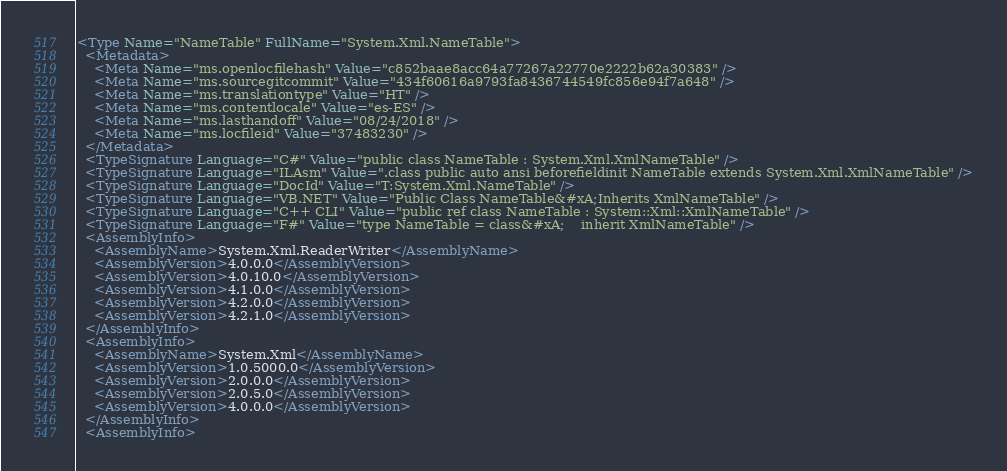<code> <loc_0><loc_0><loc_500><loc_500><_XML_><Type Name="NameTable" FullName="System.Xml.NameTable">
  <Metadata>
    <Meta Name="ms.openlocfilehash" Value="c852baae8acc64a77267a22770e2222b62a30383" />
    <Meta Name="ms.sourcegitcommit" Value="434f60616a9793fa8436744549fc856e94f7a648" />
    <Meta Name="ms.translationtype" Value="HT" />
    <Meta Name="ms.contentlocale" Value="es-ES" />
    <Meta Name="ms.lasthandoff" Value="08/24/2018" />
    <Meta Name="ms.locfileid" Value="37483230" />
  </Metadata>
  <TypeSignature Language="C#" Value="public class NameTable : System.Xml.XmlNameTable" />
  <TypeSignature Language="ILAsm" Value=".class public auto ansi beforefieldinit NameTable extends System.Xml.XmlNameTable" />
  <TypeSignature Language="DocId" Value="T:System.Xml.NameTable" />
  <TypeSignature Language="VB.NET" Value="Public Class NameTable&#xA;Inherits XmlNameTable" />
  <TypeSignature Language="C++ CLI" Value="public ref class NameTable : System::Xml::XmlNameTable" />
  <TypeSignature Language="F#" Value="type NameTable = class&#xA;    inherit XmlNameTable" />
  <AssemblyInfo>
    <AssemblyName>System.Xml.ReaderWriter</AssemblyName>
    <AssemblyVersion>4.0.0.0</AssemblyVersion>
    <AssemblyVersion>4.0.10.0</AssemblyVersion>
    <AssemblyVersion>4.1.0.0</AssemblyVersion>
    <AssemblyVersion>4.2.0.0</AssemblyVersion>
    <AssemblyVersion>4.2.1.0</AssemblyVersion>
  </AssemblyInfo>
  <AssemblyInfo>
    <AssemblyName>System.Xml</AssemblyName>
    <AssemblyVersion>1.0.5000.0</AssemblyVersion>
    <AssemblyVersion>2.0.0.0</AssemblyVersion>
    <AssemblyVersion>2.0.5.0</AssemblyVersion>
    <AssemblyVersion>4.0.0.0</AssemblyVersion>
  </AssemblyInfo>
  <AssemblyInfo></code> 